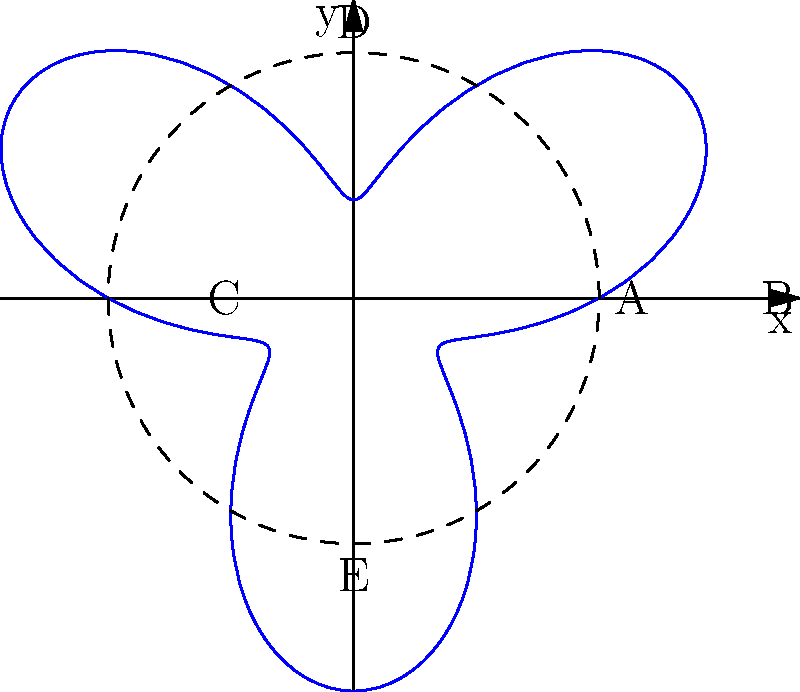The polar graph above represents the cyclical nature of investment returns over a 6-year period, with the radial distance indicating the percentage return and the angle representing time. If the dashed circle represents the average return of 5%, what is the maximum percentage return achieved during this period? To solve this problem, we need to follow these steps:

1) Observe that the graph oscillates around the dashed circle, which represents the average return of 5%.

2) The maximum return occurs at the point furthest from the origin.

3) This point is labeled as "B" on the positive x-axis.

4) The distance from the origin to point "B" represents the maximum return.

5) We can see that this distance is composed of two parts:
   - The radius of the dashed circle (5%)
   - The maximum amplitude of the oscillation

6) The maximum amplitude is the distance from the dashed circle to point "B".

7) By visual estimation, this amplitude appears to be about 3%.

8) Therefore, the maximum return is the sum of the average return and the maximum amplitude:

   $5\% + 3\% = 8\%$

Thus, the maximum percentage return achieved during this period is approximately 8%.
Answer: 8% 